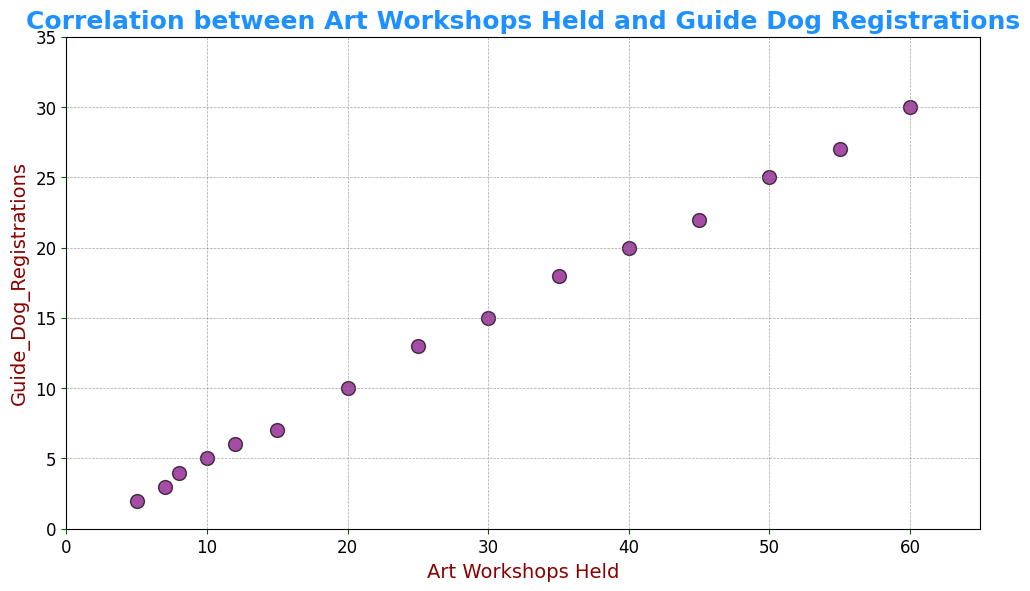What is the range of Guide Dog Registrations? The range is found by taking the difference between the maximum and minimum values of Guide Dog Registrations. From the scatter plot, the maximum is 30, and the minimum is 2. So, the range is 30 - 2 = 28.
Answer: 28 How many Guide Dog Registrations occur when 20 art workshops are held? Locate the data point where the x-axis (Art Workshops Held) is 20. The y-axis (Guide Dog Registrations) corresponding to this point is 10.
Answer: 10 Is there a trend between the number of art workshops held and guide dog registrations? Observing the scatter plot, the points trend upward from left to right, suggesting a positive correlation. As the number of art workshops held increases, so do the guide dog registrations.
Answer: Yes, a positive trend Which has more dog registrations: 35 art workshops or 40 art workshops? Locate the two points on the scatter plot. For 35 workshops, Guide Dog Registrations are 18, and for 40 workshops, they are 20. Therefore, 40 workshops have more registrations.
Answer: 40 art workshops What is the average number of guide dog registrations for 5, 10, 15, and 20 art workshops held? First, find the Guide Dog Registrations for these points: 2, 5, 7, and 10, respectively. Adding these, 2 + 5 + 7 + 10 = 24. There are 4 points, so the average is 24 / 4 = 6.
Answer: 6 Does the number of workshops ever exceed 50? Looking at the x-axis in the scatter plot, the number of workshops goes up to 60. Thus, it exceeds 50.
Answer: Yes Are there more art workshops held when guide dog registrations are exactly 6 or exactly 15? For 6 registrations, the corresponding workshops held are 12. For 15 registrations, the corresponding workshops held are 30. Hence, more workshops are held for 15 registrations.
Answer: 15 registrations What is the difference in Guide Dog Registrations between 25 and 50 art workshops held? Locate the points on the scatter plot. Registrations for 25 workshops are 13, and for 50 workshops are 25. The difference is 25 - 13 = 12.
Answer: 12 What is the color of the points used in the scatter plot? Observing the color of the data points in the scatter plot, they are purple.
Answer: Purple How many guide dog registrations are there for every 10 workshops held initially (e.g., 10, 20, 30)? At 10 workshops, registrations are 5; at 20 workshops, they are 10; at 30 workshops, they are 15. Each increment of 10 workshops results in an increment of 5 registrations.
Answer: 5 registrations for every 10 workshops 